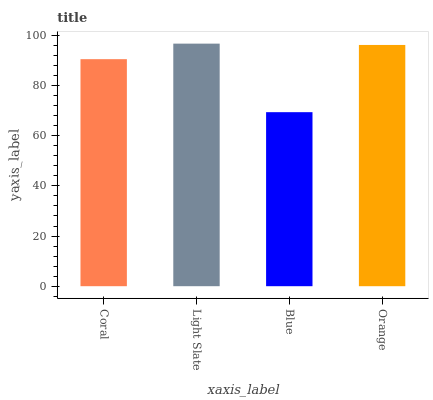Is Blue the minimum?
Answer yes or no. Yes. Is Light Slate the maximum?
Answer yes or no. Yes. Is Light Slate the minimum?
Answer yes or no. No. Is Blue the maximum?
Answer yes or no. No. Is Light Slate greater than Blue?
Answer yes or no. Yes. Is Blue less than Light Slate?
Answer yes or no. Yes. Is Blue greater than Light Slate?
Answer yes or no. No. Is Light Slate less than Blue?
Answer yes or no. No. Is Orange the high median?
Answer yes or no. Yes. Is Coral the low median?
Answer yes or no. Yes. Is Coral the high median?
Answer yes or no. No. Is Light Slate the low median?
Answer yes or no. No. 